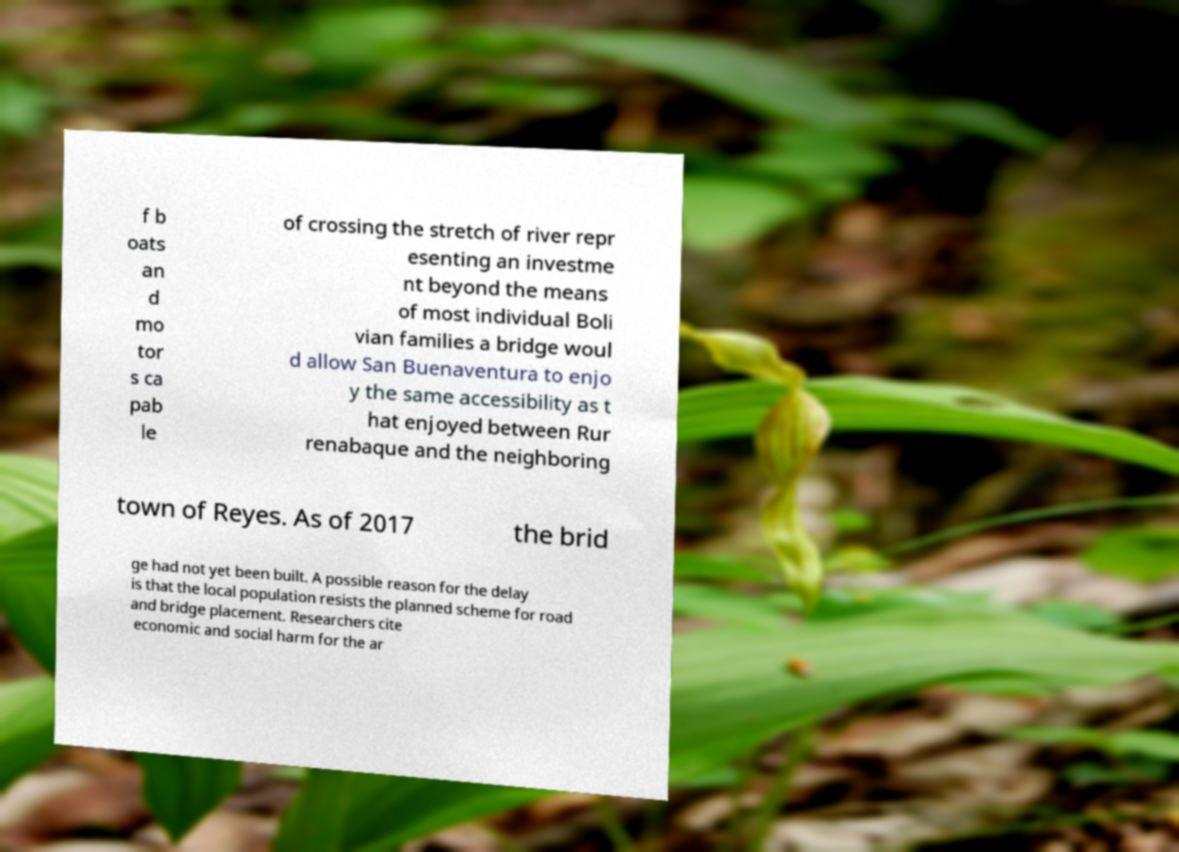Can you read and provide the text displayed in the image?This photo seems to have some interesting text. Can you extract and type it out for me? f b oats an d mo tor s ca pab le of crossing the stretch of river repr esenting an investme nt beyond the means of most individual Boli vian families a bridge woul d allow San Buenaventura to enjo y the same accessibility as t hat enjoyed between Rur renabaque and the neighboring town of Reyes. As of 2017 the brid ge had not yet been built. A possible reason for the delay is that the local population resists the planned scheme for road and bridge placement. Researchers cite economic and social harm for the ar 